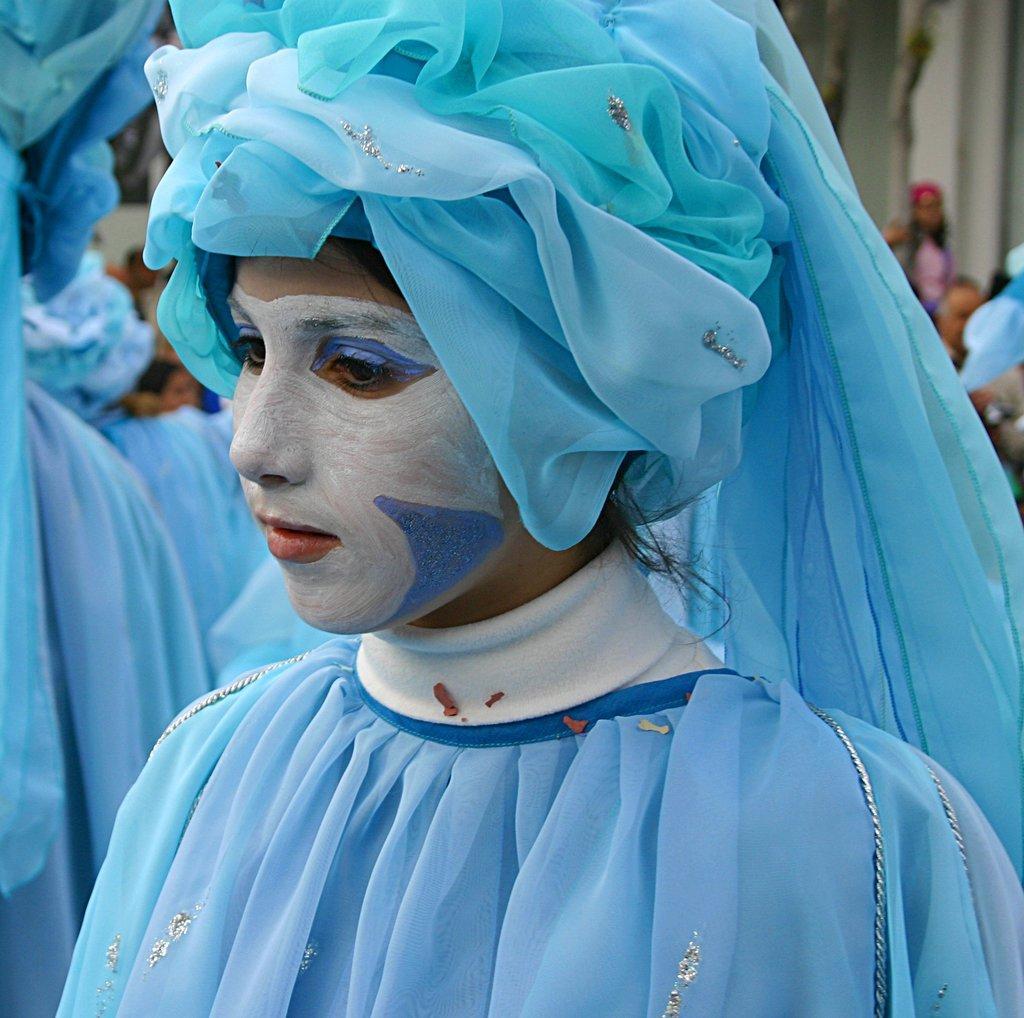In one or two sentences, can you explain what this image depicts? In this image there is a woman who is wearing the blue colour dress and blue colour cap. There is a white colour painting on the face of the woman. In the background there are few other people who are wearing the blue color dress. 